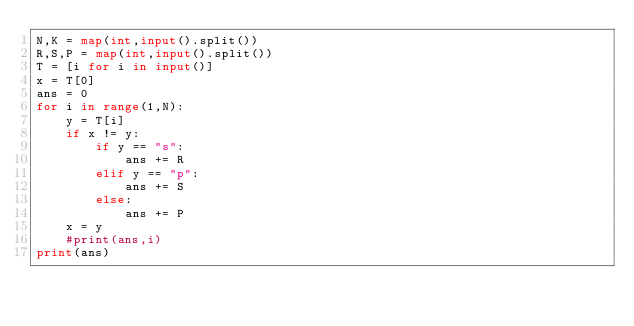Convert code to text. <code><loc_0><loc_0><loc_500><loc_500><_Python_>N,K = map(int,input().split())
R,S,P = map(int,input().split())
T = [i for i in input()]
x = T[0]
ans = 0
for i in range(1,N):
    y = T[i]
    if x != y:
        if y == "s":
            ans += R
        elif y == "p":
            ans += S
        else:
            ans += P
    x = y
    #print(ans,i)
print(ans)</code> 